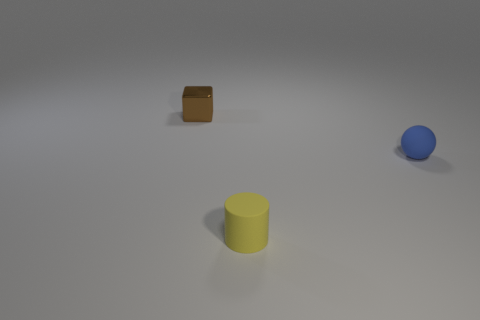What materials are the objects made of, and how can you tell? The brown cube looks like it's made of metal due to its reflective surface and color, suggesting it might be a type of rusted metal. The blue sphere seems matte and could be made of plastic or rubber, given its non-reflective surface. Lastly, the yellow cylinder has a slightly shiny surface, hinting it might be made of a polished plastic or a metal with a paint coating. 